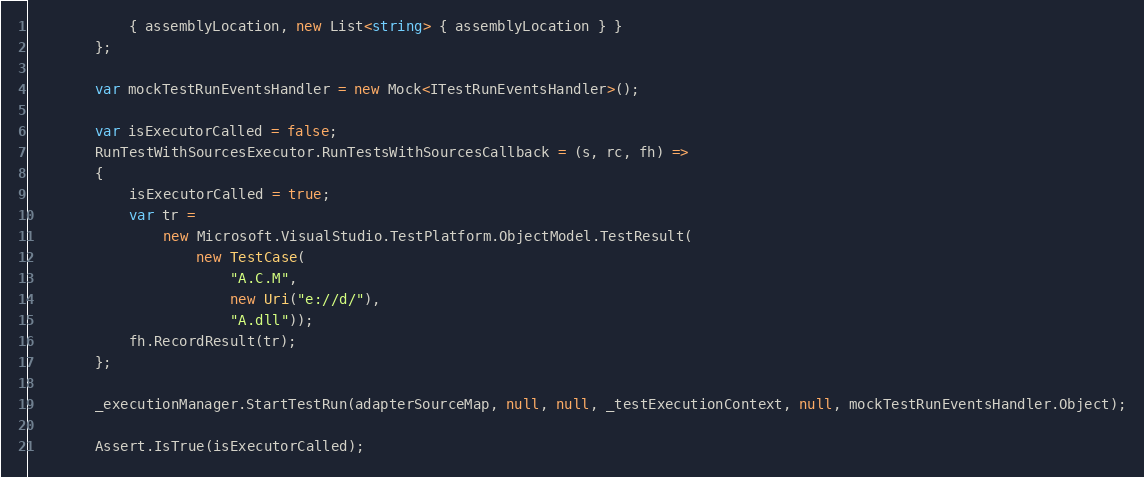Convert code to text. <code><loc_0><loc_0><loc_500><loc_500><_C#_>            { assemblyLocation, new List<string> { assemblyLocation } }
        };

        var mockTestRunEventsHandler = new Mock<ITestRunEventsHandler>();

        var isExecutorCalled = false;
        RunTestWithSourcesExecutor.RunTestsWithSourcesCallback = (s, rc, fh) =>
        {
            isExecutorCalled = true;
            var tr =
                new Microsoft.VisualStudio.TestPlatform.ObjectModel.TestResult(
                    new TestCase(
                        "A.C.M",
                        new Uri("e://d/"),
                        "A.dll"));
            fh.RecordResult(tr);
        };

        _executionManager.StartTestRun(adapterSourceMap, null, null, _testExecutionContext, null, mockTestRunEventsHandler.Object);

        Assert.IsTrue(isExecutorCalled);</code> 